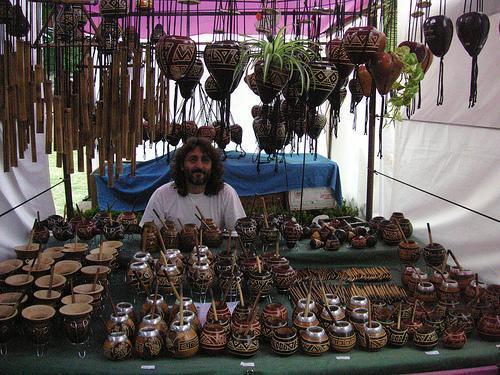How many tabels have a blue cover on them?
Give a very brief answer. 1. 